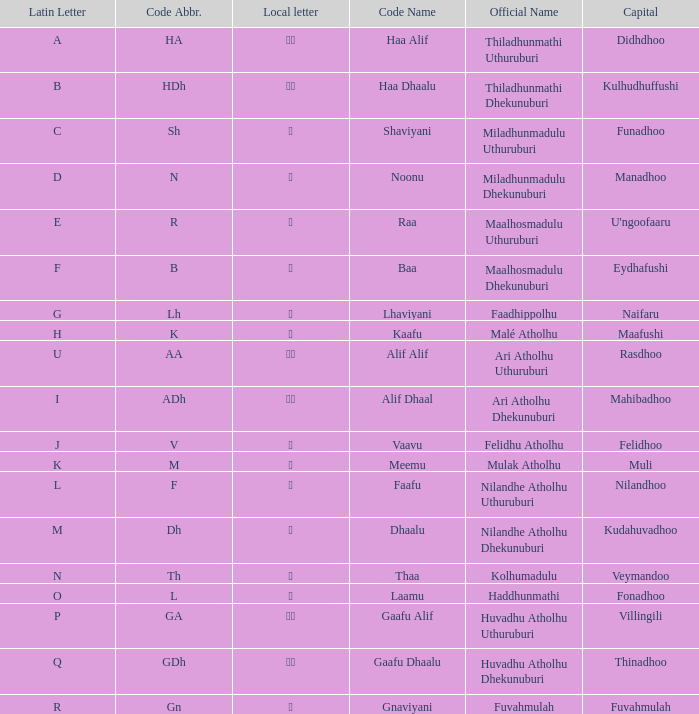The capital of funadhoo has what local letter? ށ. 